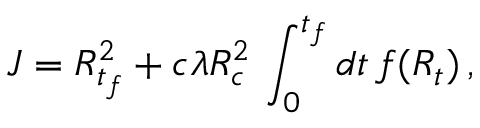Convert formula to latex. <formula><loc_0><loc_0><loc_500><loc_500>J = R _ { t _ { f } } ^ { 2 } + c \lambda R _ { c } ^ { 2 } \, \int _ { 0 } ^ { t _ { f } } { d t \, f ( R _ { t } ) } \, ,</formula> 